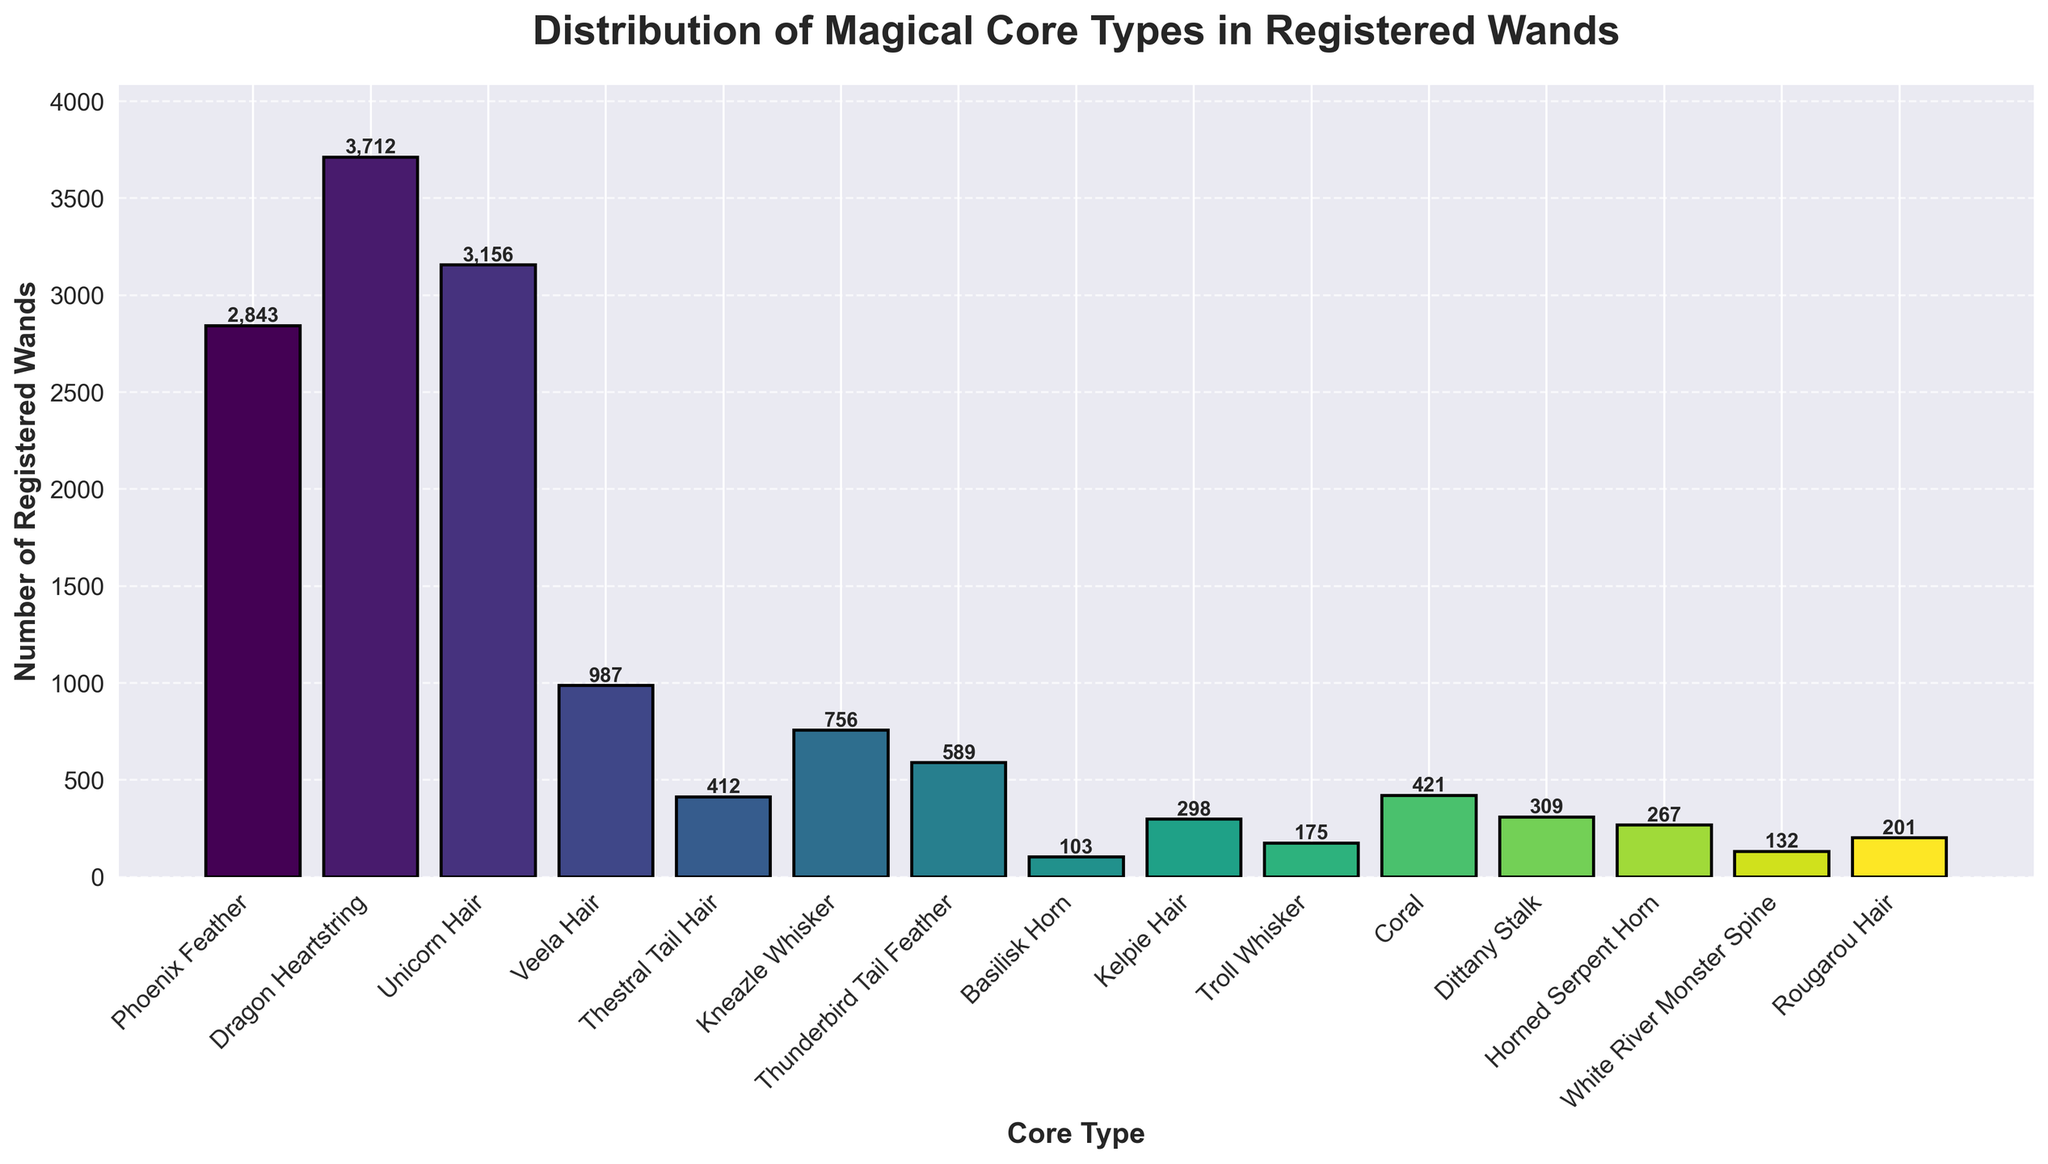What core type has the highest number of registered wands? The figure shows that "Dragon Heartstring" has the tallest bar, indicating it has the highest number of registered wands at 3,712.
Answer: Dragon Heartstring Which two core types have the closest numbers of registered wands? By looking at the heights of the bars, "Unicorn Hair" and "Phoenix Feather" have close counts, with 3,156 and 2,843 wands respectively. The difference is 3,156 - 2,843 = 313.
Answer: Unicorn Hair and Phoenix Feather How many registered wands have Phoenix Feather or Unicorn Hair cores combined? Adding the numbers for Phoenix Feather (2,843) and Unicorn Hair (3,156) gives a total of 2,843 + 3,156 = 5,999.
Answer: 5,999 What is the average number of registered wands for the core types displayed? First, sum all the registered wands: 2,843 + 3,712 + 3,156 + 987 + 412 + 756 + 589 + 103 + 298 + 175 + 421 + 309 + 267 + 132 + 201 = 14,361. There are 15 core types, so the average is 14,361 / 15 = 957.4.
Answer: 957.4 Which core type has the fewest registered wands and how many does it have? The shortest bar corresponds to "Basilisk Horn" with 103 registered wands.
Answer: Basilisk Horn What is the total number of registered wands for Kelpie Hair and Troll Whisker combined? Adding the numbers for Kelpie Hair (298) and Troll Whisker (175) gives 298 + 175 = 473.
Answer: 473 How much greater is the number of registered wands with Dragon Heartstring compared to the number with Kneazle Whisker? The figure shows 3,712 for Dragon Heartstring and 756 for Kneazle Whisker. The difference is 3,712 - 756 = 2,956.
Answer: 2,956 Which core type has a slightly higher number of registered wands: Dittany Stalk or Kelpie Hair? By comparing the heights of the bars, "Dittany Stalk" has 309 and "Kelpie Hair" has 298. Dittany Stalk is slightly higher by 309 - 298 = 11.
Answer: Dittany Stalk What is the total number of registered wands for all core types with less than 300 registered wands? Summing the numbers for Basilisk Horn (103), Kelpie Hair (298), Troll Whisker (175), Horned Serpent Horn (267), and White River Monster Spine (132) gives 103 + 298 + 175 + 267 + 132 = 975.
Answer: 975 Which core type has the most visually distinct color and how many registered wands does it correspond to? From the gradient used, the bar for "Dragon Heartstring" is a dark shade, which stands out. It corresponds to 3,712 wands.
Answer: Dragon Heartstring 